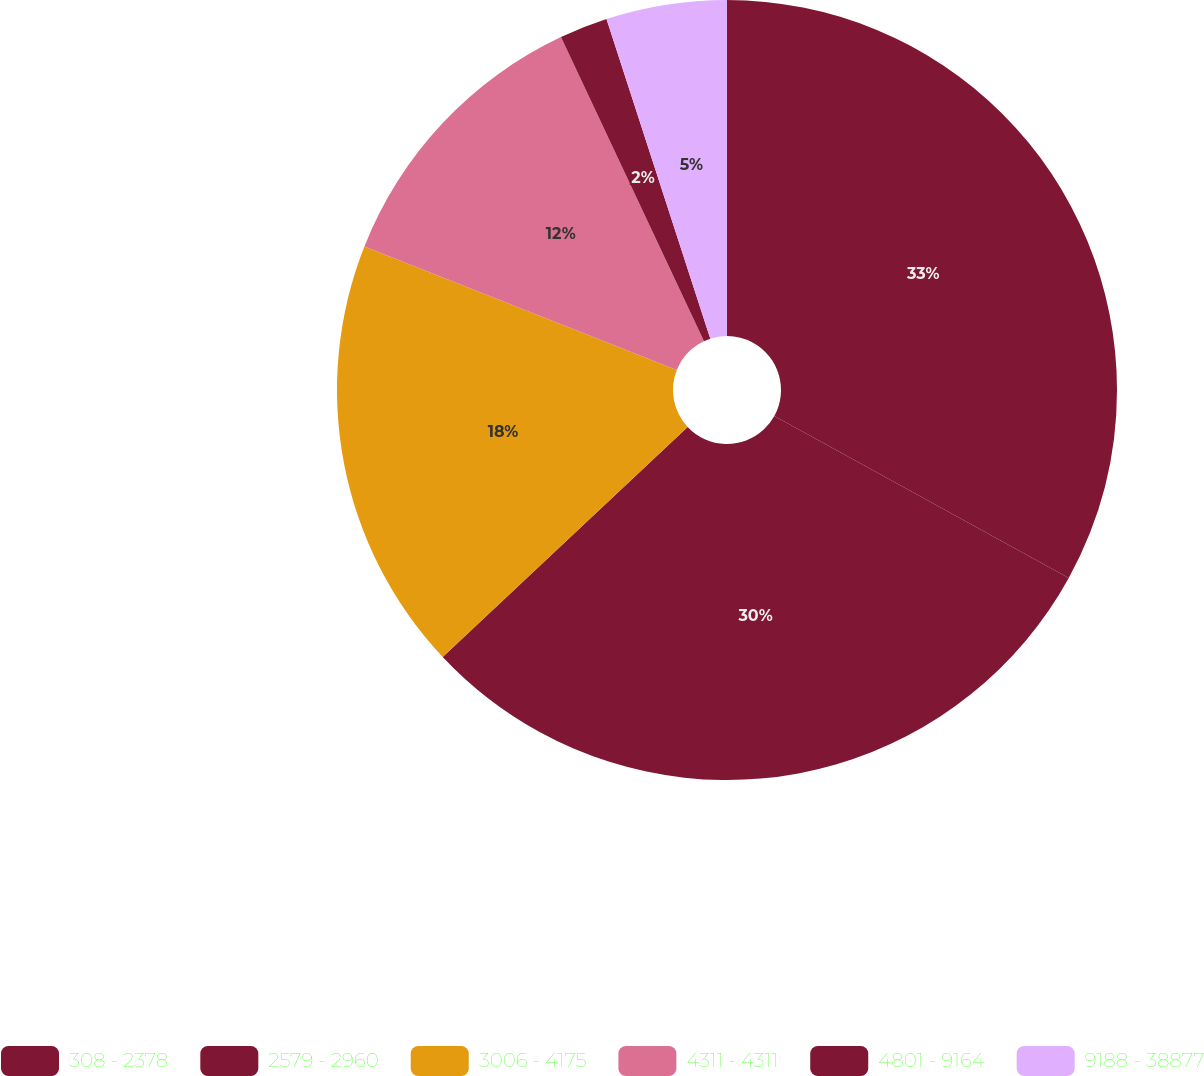<chart> <loc_0><loc_0><loc_500><loc_500><pie_chart><fcel>308 - 2378<fcel>2579 - 2960<fcel>3006 - 4175<fcel>4311 - 4311<fcel>4801 - 9164<fcel>9188 - 38877<nl><fcel>33.0%<fcel>30.0%<fcel>18.0%<fcel>12.0%<fcel>2.0%<fcel>5.0%<nl></chart> 